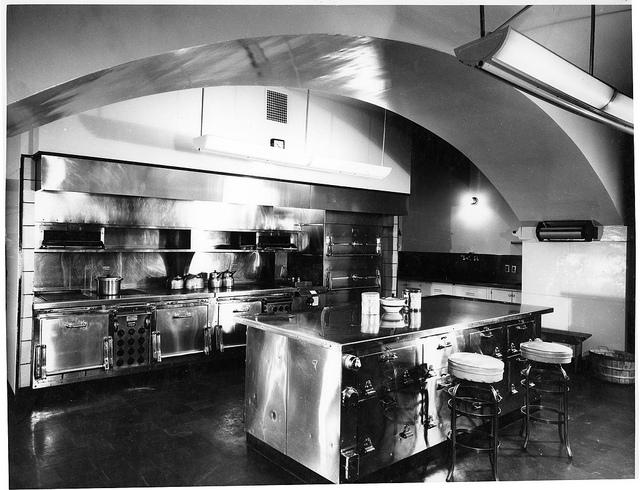Where are the backless stools?
Short answer required. Counter. What is on the counter?
Keep it brief. Napkins. Is the light in the kitchen on?
Be succinct. Yes. 